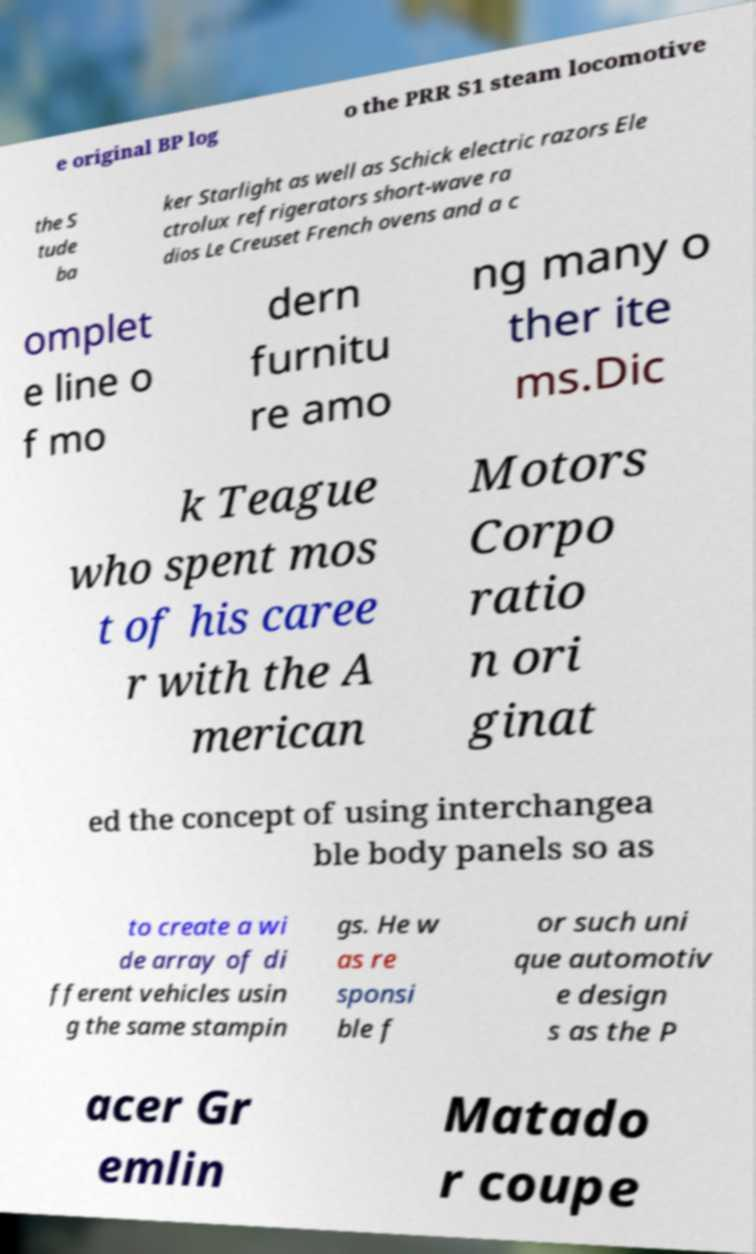I need the written content from this picture converted into text. Can you do that? e original BP log o the PRR S1 steam locomotive the S tude ba ker Starlight as well as Schick electric razors Ele ctrolux refrigerators short-wave ra dios Le Creuset French ovens and a c omplet e line o f mo dern furnitu re amo ng many o ther ite ms.Dic k Teague who spent mos t of his caree r with the A merican Motors Corpo ratio n ori ginat ed the concept of using interchangea ble body panels so as to create a wi de array of di fferent vehicles usin g the same stampin gs. He w as re sponsi ble f or such uni que automotiv e design s as the P acer Gr emlin Matado r coupe 